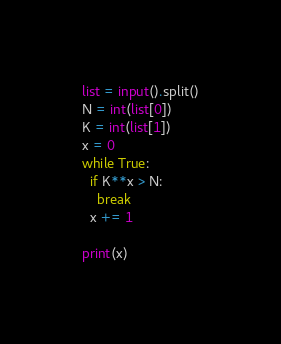Convert code to text. <code><loc_0><loc_0><loc_500><loc_500><_Python_>list = input().split()
N = int(list[0])
K = int(list[1])
x = 0
while True:
  if K**x > N:
    break
  x += 1
    
print(x)</code> 